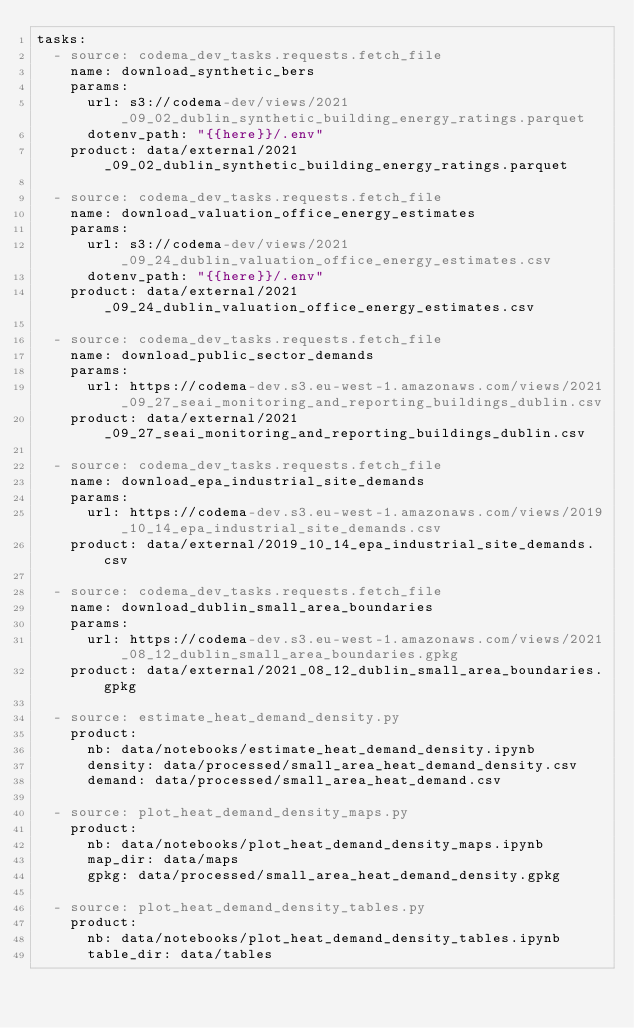<code> <loc_0><loc_0><loc_500><loc_500><_YAML_>tasks:
  - source: codema_dev_tasks.requests.fetch_file
    name: download_synthetic_bers
    params:
      url: s3://codema-dev/views/2021_09_02_dublin_synthetic_building_energy_ratings.parquet
      dotenv_path: "{{here}}/.env"
    product: data/external/2021_09_02_dublin_synthetic_building_energy_ratings.parquet
  
  - source: codema_dev_tasks.requests.fetch_file
    name: download_valuation_office_energy_estimates
    params:
      url: s3://codema-dev/views/2021_09_24_dublin_valuation_office_energy_estimates.csv
      dotenv_path: "{{here}}/.env"
    product: data/external/2021_09_24_dublin_valuation_office_energy_estimates.csv

  - source: codema_dev_tasks.requests.fetch_file
    name: download_public_sector_demands
    params:
      url: https://codema-dev.s3.eu-west-1.amazonaws.com/views/2021_09_27_seai_monitoring_and_reporting_buildings_dublin.csv
    product: data/external/2021_09_27_seai_monitoring_and_reporting_buildings_dublin.csv
  
  - source: codema_dev_tasks.requests.fetch_file
    name: download_epa_industrial_site_demands
    params:
      url: https://codema-dev.s3.eu-west-1.amazonaws.com/views/2019_10_14_epa_industrial_site_demands.csv
    product: data/external/2019_10_14_epa_industrial_site_demands.csv

  - source: codema_dev_tasks.requests.fetch_file
    name: download_dublin_small_area_boundaries
    params:
      url: https://codema-dev.s3.eu-west-1.amazonaws.com/views/2021_08_12_dublin_small_area_boundaries.gpkg
    product: data/external/2021_08_12_dublin_small_area_boundaries.gpkg

  - source: estimate_heat_demand_density.py
    product:
      nb: data/notebooks/estimate_heat_demand_density.ipynb
      density: data/processed/small_area_heat_demand_density.csv
      demand: data/processed/small_area_heat_demand.csv
  
  - source: plot_heat_demand_density_maps.py
    product:
      nb: data/notebooks/plot_heat_demand_density_maps.ipynb
      map_dir: data/maps
      gpkg: data/processed/small_area_heat_demand_density.gpkg

  - source: plot_heat_demand_density_tables.py
    product:
      nb: data/notebooks/plot_heat_demand_density_tables.ipynb
      table_dir: data/tables</code> 